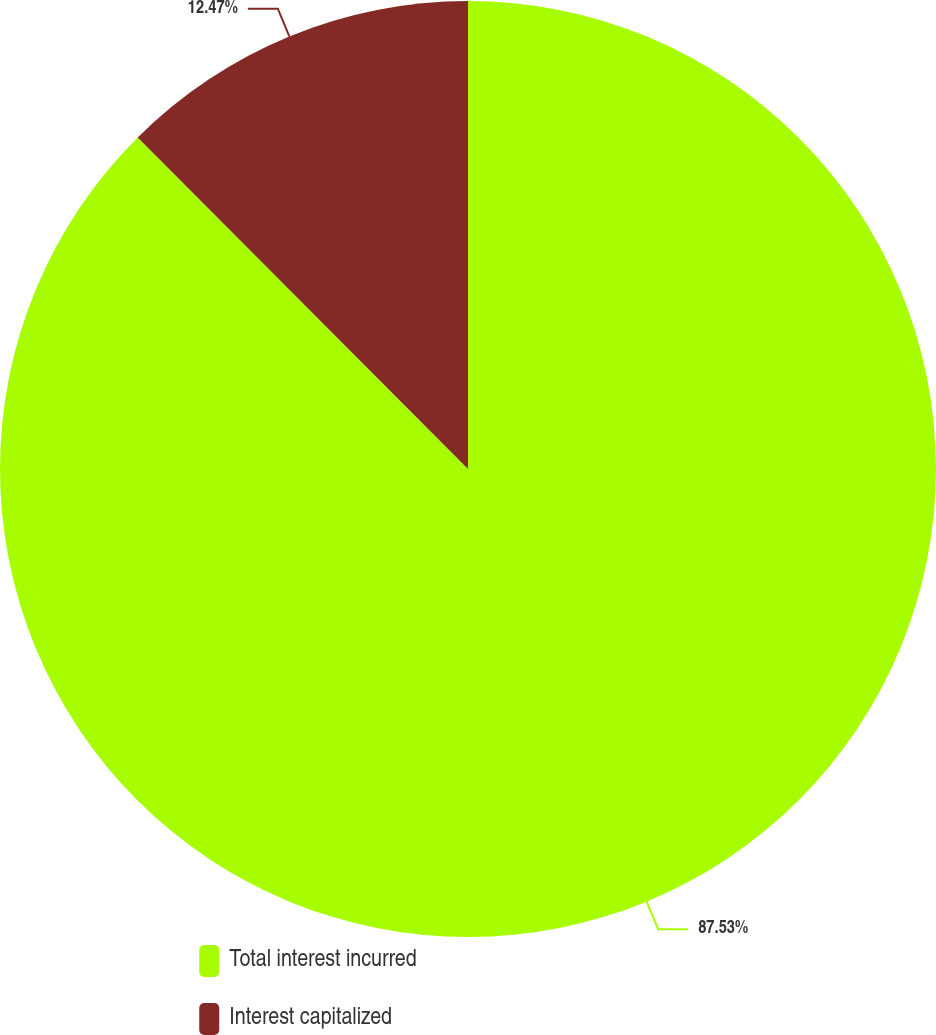Convert chart to OTSL. <chart><loc_0><loc_0><loc_500><loc_500><pie_chart><fcel>Total interest incurred<fcel>Interest capitalized<nl><fcel>87.53%<fcel>12.47%<nl></chart> 